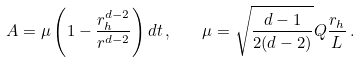Convert formula to latex. <formula><loc_0><loc_0><loc_500><loc_500>A = \mu \left ( 1 - \frac { r _ { h } ^ { d - 2 } } { r ^ { d - 2 } } \right ) d t \, , \quad \mu = \sqrt { \frac { d - 1 } { 2 ( d - 2 ) } } Q \frac { r _ { h } } L \, .</formula> 